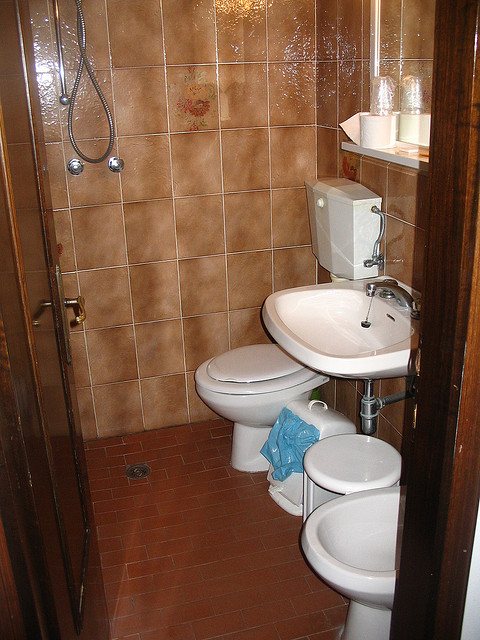I notice there's a shower; what are some features or accessories that can be added for a better shower experience? Enhancing a shower experience can include installing a multi-function showerhead for different water pressures and patterns, adding a corner shelf or caddy for toiletries, incorporating a waterproof Bluetooth speaker for music, and ensuring good lighting and ventilation. 